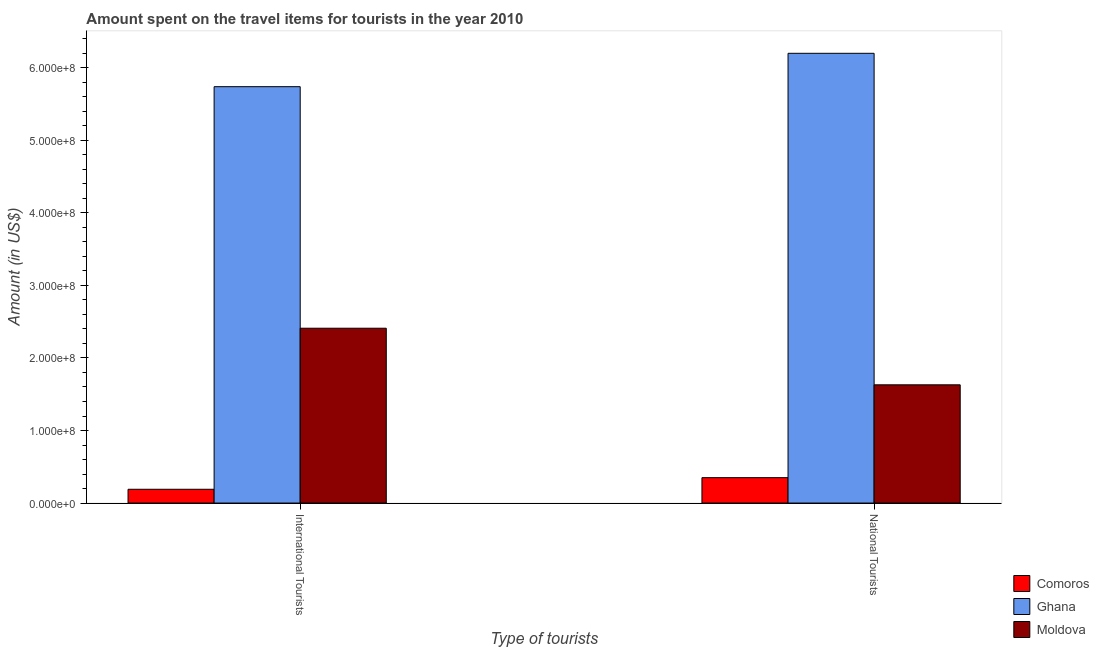How many groups of bars are there?
Make the answer very short. 2. Are the number of bars per tick equal to the number of legend labels?
Your answer should be compact. Yes. Are the number of bars on each tick of the X-axis equal?
Your answer should be compact. Yes. How many bars are there on the 2nd tick from the left?
Provide a succinct answer. 3. What is the label of the 1st group of bars from the left?
Your answer should be compact. International Tourists. What is the amount spent on travel items of international tourists in Comoros?
Your response must be concise. 1.90e+07. Across all countries, what is the maximum amount spent on travel items of international tourists?
Your answer should be very brief. 5.74e+08. Across all countries, what is the minimum amount spent on travel items of national tourists?
Give a very brief answer. 3.50e+07. In which country was the amount spent on travel items of national tourists minimum?
Your response must be concise. Comoros. What is the total amount spent on travel items of national tourists in the graph?
Your response must be concise. 8.18e+08. What is the difference between the amount spent on travel items of national tourists in Ghana and that in Moldova?
Keep it short and to the point. 4.57e+08. What is the difference between the amount spent on travel items of international tourists in Moldova and the amount spent on travel items of national tourists in Ghana?
Make the answer very short. -3.79e+08. What is the average amount spent on travel items of international tourists per country?
Your answer should be very brief. 2.78e+08. What is the difference between the amount spent on travel items of international tourists and amount spent on travel items of national tourists in Moldova?
Your response must be concise. 7.80e+07. What is the ratio of the amount spent on travel items of international tourists in Moldova to that in Ghana?
Ensure brevity in your answer.  0.42. Is the amount spent on travel items of national tourists in Comoros less than that in Ghana?
Make the answer very short. Yes. In how many countries, is the amount spent on travel items of international tourists greater than the average amount spent on travel items of international tourists taken over all countries?
Keep it short and to the point. 1. What does the 2nd bar from the left in National Tourists represents?
Ensure brevity in your answer.  Ghana. Are the values on the major ticks of Y-axis written in scientific E-notation?
Ensure brevity in your answer.  Yes. Where does the legend appear in the graph?
Make the answer very short. Bottom right. How many legend labels are there?
Keep it short and to the point. 3. How are the legend labels stacked?
Make the answer very short. Vertical. What is the title of the graph?
Offer a very short reply. Amount spent on the travel items for tourists in the year 2010. What is the label or title of the X-axis?
Your answer should be compact. Type of tourists. What is the label or title of the Y-axis?
Your answer should be compact. Amount (in US$). What is the Amount (in US$) in Comoros in International Tourists?
Make the answer very short. 1.90e+07. What is the Amount (in US$) of Ghana in International Tourists?
Provide a short and direct response. 5.74e+08. What is the Amount (in US$) in Moldova in International Tourists?
Give a very brief answer. 2.41e+08. What is the Amount (in US$) of Comoros in National Tourists?
Keep it short and to the point. 3.50e+07. What is the Amount (in US$) of Ghana in National Tourists?
Your answer should be compact. 6.20e+08. What is the Amount (in US$) in Moldova in National Tourists?
Your response must be concise. 1.63e+08. Across all Type of tourists, what is the maximum Amount (in US$) in Comoros?
Your answer should be very brief. 3.50e+07. Across all Type of tourists, what is the maximum Amount (in US$) in Ghana?
Your response must be concise. 6.20e+08. Across all Type of tourists, what is the maximum Amount (in US$) in Moldova?
Ensure brevity in your answer.  2.41e+08. Across all Type of tourists, what is the minimum Amount (in US$) of Comoros?
Give a very brief answer. 1.90e+07. Across all Type of tourists, what is the minimum Amount (in US$) of Ghana?
Ensure brevity in your answer.  5.74e+08. Across all Type of tourists, what is the minimum Amount (in US$) of Moldova?
Offer a very short reply. 1.63e+08. What is the total Amount (in US$) in Comoros in the graph?
Ensure brevity in your answer.  5.40e+07. What is the total Amount (in US$) in Ghana in the graph?
Your answer should be compact. 1.19e+09. What is the total Amount (in US$) of Moldova in the graph?
Keep it short and to the point. 4.04e+08. What is the difference between the Amount (in US$) in Comoros in International Tourists and that in National Tourists?
Make the answer very short. -1.60e+07. What is the difference between the Amount (in US$) in Ghana in International Tourists and that in National Tourists?
Offer a very short reply. -4.60e+07. What is the difference between the Amount (in US$) of Moldova in International Tourists and that in National Tourists?
Provide a short and direct response. 7.80e+07. What is the difference between the Amount (in US$) in Comoros in International Tourists and the Amount (in US$) in Ghana in National Tourists?
Offer a terse response. -6.01e+08. What is the difference between the Amount (in US$) in Comoros in International Tourists and the Amount (in US$) in Moldova in National Tourists?
Your answer should be compact. -1.44e+08. What is the difference between the Amount (in US$) of Ghana in International Tourists and the Amount (in US$) of Moldova in National Tourists?
Your answer should be very brief. 4.11e+08. What is the average Amount (in US$) of Comoros per Type of tourists?
Give a very brief answer. 2.70e+07. What is the average Amount (in US$) in Ghana per Type of tourists?
Make the answer very short. 5.97e+08. What is the average Amount (in US$) of Moldova per Type of tourists?
Your response must be concise. 2.02e+08. What is the difference between the Amount (in US$) in Comoros and Amount (in US$) in Ghana in International Tourists?
Ensure brevity in your answer.  -5.55e+08. What is the difference between the Amount (in US$) of Comoros and Amount (in US$) of Moldova in International Tourists?
Make the answer very short. -2.22e+08. What is the difference between the Amount (in US$) of Ghana and Amount (in US$) of Moldova in International Tourists?
Make the answer very short. 3.33e+08. What is the difference between the Amount (in US$) of Comoros and Amount (in US$) of Ghana in National Tourists?
Provide a succinct answer. -5.85e+08. What is the difference between the Amount (in US$) of Comoros and Amount (in US$) of Moldova in National Tourists?
Provide a succinct answer. -1.28e+08. What is the difference between the Amount (in US$) in Ghana and Amount (in US$) in Moldova in National Tourists?
Provide a succinct answer. 4.57e+08. What is the ratio of the Amount (in US$) in Comoros in International Tourists to that in National Tourists?
Your answer should be compact. 0.54. What is the ratio of the Amount (in US$) of Ghana in International Tourists to that in National Tourists?
Keep it short and to the point. 0.93. What is the ratio of the Amount (in US$) in Moldova in International Tourists to that in National Tourists?
Make the answer very short. 1.48. What is the difference between the highest and the second highest Amount (in US$) of Comoros?
Give a very brief answer. 1.60e+07. What is the difference between the highest and the second highest Amount (in US$) in Ghana?
Offer a very short reply. 4.60e+07. What is the difference between the highest and the second highest Amount (in US$) of Moldova?
Keep it short and to the point. 7.80e+07. What is the difference between the highest and the lowest Amount (in US$) in Comoros?
Give a very brief answer. 1.60e+07. What is the difference between the highest and the lowest Amount (in US$) in Ghana?
Make the answer very short. 4.60e+07. What is the difference between the highest and the lowest Amount (in US$) of Moldova?
Your answer should be very brief. 7.80e+07. 